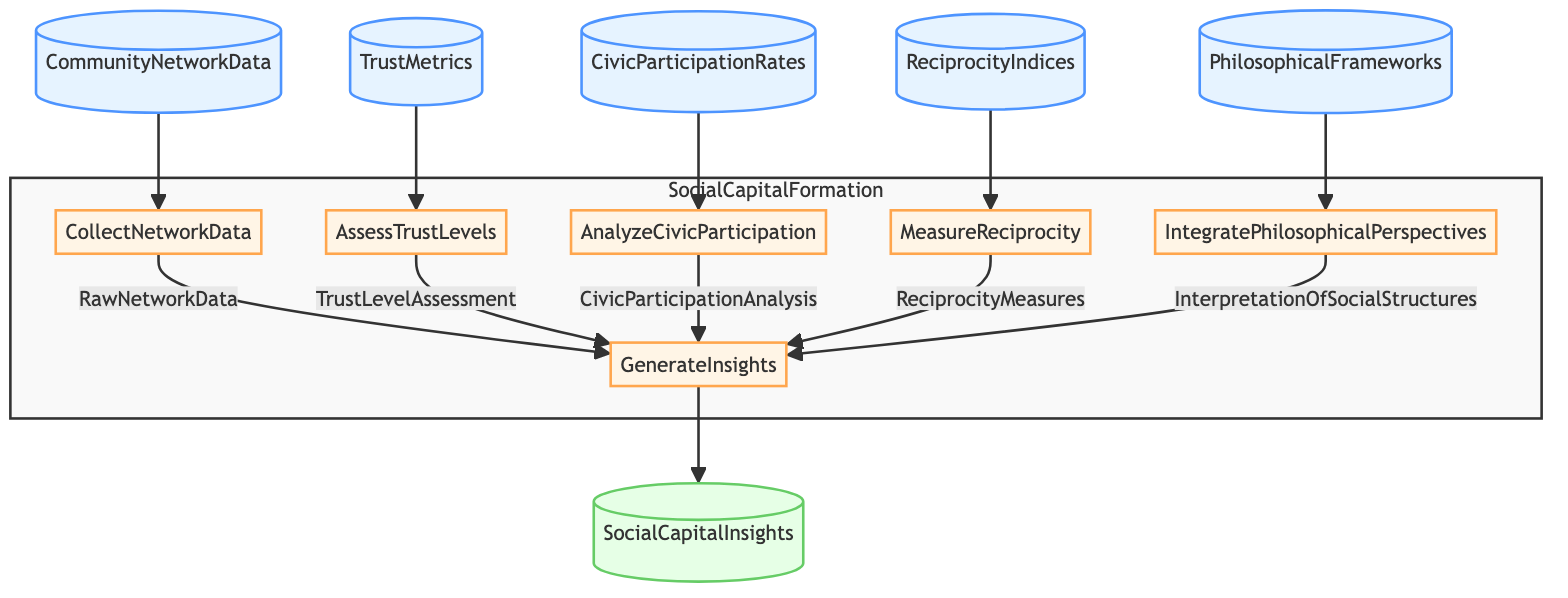What is the first step in the social capital formation process? The first step is "CollectNetworkData," as it is the first action listed in the flowchart, directly following the community network data input.
Answer: CollectNetworkData How many input nodes are there in the diagram? The diagram shows five input nodes: CommunityNetworkData, TrustMetrics, CivicParticipationRates, ReciprocityIndices, and PhilosophicalFrameworks, counted directly from the visual representation.
Answer: 5 What is the output of the function? The output of the function is "SocialCapitalInsights," which is clearly indicated as the final output node in the flowchart.
Answer: SocialCapitalInsights Which step analyzes civic participation rates? The step that analyzes civic participation rates is "AnalyzeCivicParticipation," as labeled in the flowchart among the process steps.
Answer: AnalyzeCivicParticipation How many steps need to be completed before generating insights? Five steps need to be completed before generating insights, as indicated in the flowchart where each of the five steps feeds into the "GenerateInsights" step.
Answer: 5 What type of data is assessed in the "AssessTrustLevels" step? The "AssessTrustLevels" step assesses trust levels within the community using TrustMetrics, which is specified as input for that step.
Answer: TrustMetrics What is combined to generate insights? Insights are generated by combining RawNetworkData, TrustLevelAssessment, CivicParticipationAnalysis, ReciprocityMeasures, and InterpretationOfSocialStructures, as per their connections in the flowchart.
Answer: RawNetworkData, TrustLevelAssessment, CivicParticipationAnalysis, ReciprocityMeasures, InterpretationOfSocialStructures Which philosophical aspect is integrated into the social capital formation process? "IntegratePhilosophicalPerspectives" integrates philosophical frameworks into the process, as indicated in the designated step of the flowchart.
Answer: IntegratePhilosophicalPerspectives What connects the step "MeasureReciprocity" to the insights generation? The output from "MeasureReciprocity" is "ReciprocityMeasures," which connects this step to the "GenerateInsights" step, as reflected in the flow of the flowchart.
Answer: ReciprocityMeasures What step comes after "CollectNetworkData"? The step that comes after "CollectNetworkData" is "AssessTrustLevels," indicated by the subsequent arrow in the flowchart flow.
Answer: AssessTrustLevels 